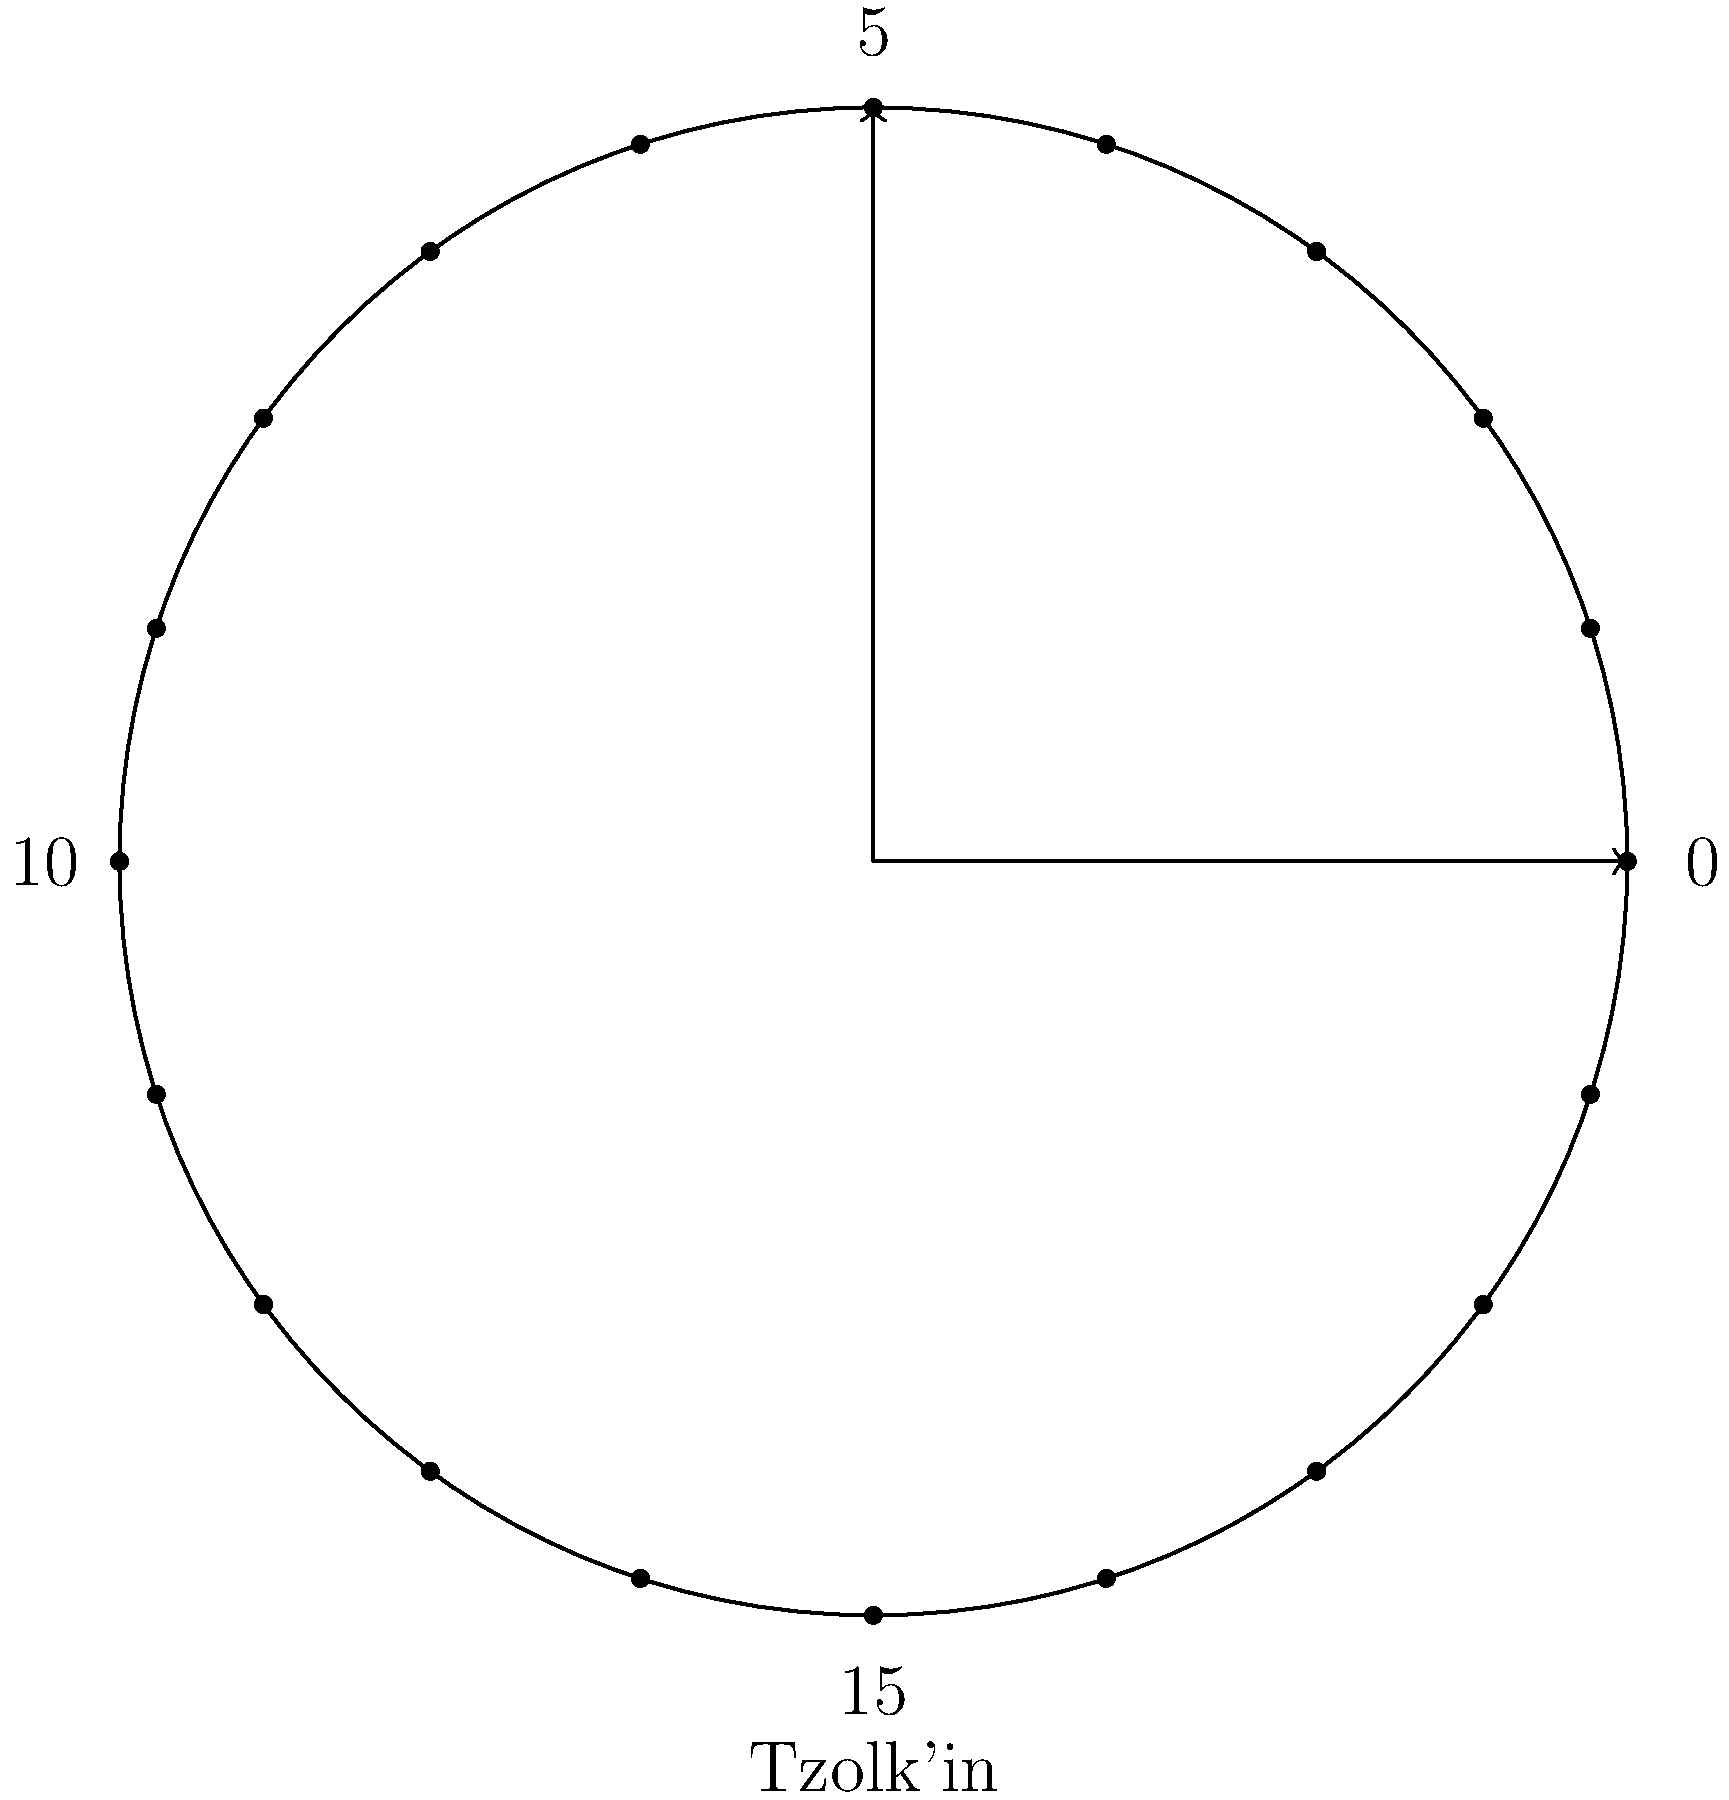In the Mayan Tzolk'in calendar, represented by the circular glyph above, each day is associated with a number from 1 to 13 and one of 20 day names. If a particular day is represented by the number 4 and the 7th day name, how many days will pass before this exact combination occurs again? To solve this problem, we need to understand the cyclical nature of the Tzolk'in calendar and use the concept of least common multiple (LCM).

1. The Tzolk'in calendar has two simultaneous cycles:
   - A cycle of 13 numbers (1 to 13)
   - A cycle of 20 day names

2. We need to find how many days it takes for both cycles to align again at the same point (4 and 7th day name).

3. This is equivalent to finding the LCM of 13 and 20.

4. To calculate the LCM:
   a) First, find the prime factorization of both numbers:
      13 = 13 (prime)
      20 = 2² × 5
   b) Take each prime factor to the highest power in which it occurs in either number:
      LCM = 2² × 5 × 13

5. Calculate the result:
   LCM = 4 × 5 × 13 = 260

Therefore, the combination will repeat after 260 days, which is the length of the complete Tzolk'in calendar cycle.
Answer: 260 days 